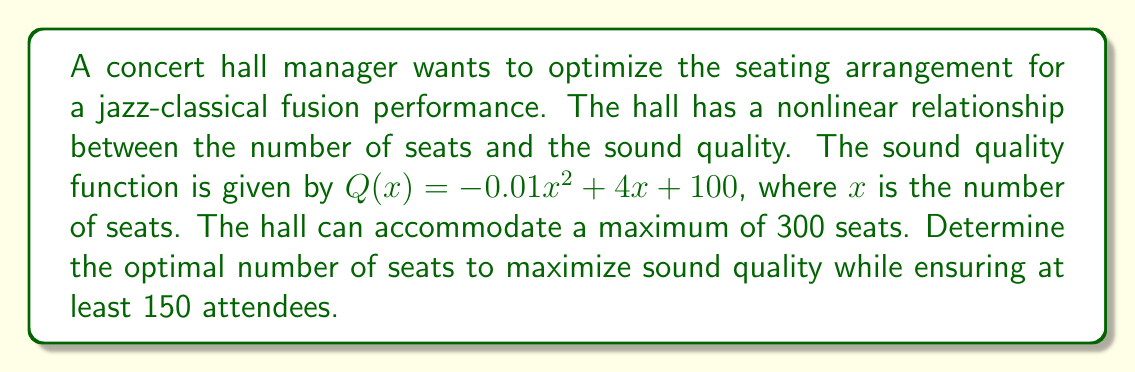What is the answer to this math problem? 1. We need to maximize the sound quality function $Q(x)$ subject to constraints.

2. The objective function is:
   $Q(x) = -0.01x^2 + 4x + 100$

3. Constraints:
   $150 \leq x \leq 300$

4. To find the maximum, we differentiate $Q(x)$ and set it to zero:
   $$\frac{dQ}{dx} = -0.02x + 4 = 0$$

5. Solving for x:
   $-0.02x = -4$
   $x = 200$

6. Check the second derivative to confirm it's a maximum:
   $$\frac{d^2Q}{dx^2} = -0.02 < 0$$
   This confirms it's a maximum.

7. Check if the solution satisfies the constraints:
   $150 \leq 200 \leq 300$
   It does satisfy the constraints.

8. Therefore, the optimal number of seats is 200.

9. The maximum sound quality is:
   $Q(200) = -0.01(200)^2 + 4(200) + 100 = 500$
Answer: 200 seats 